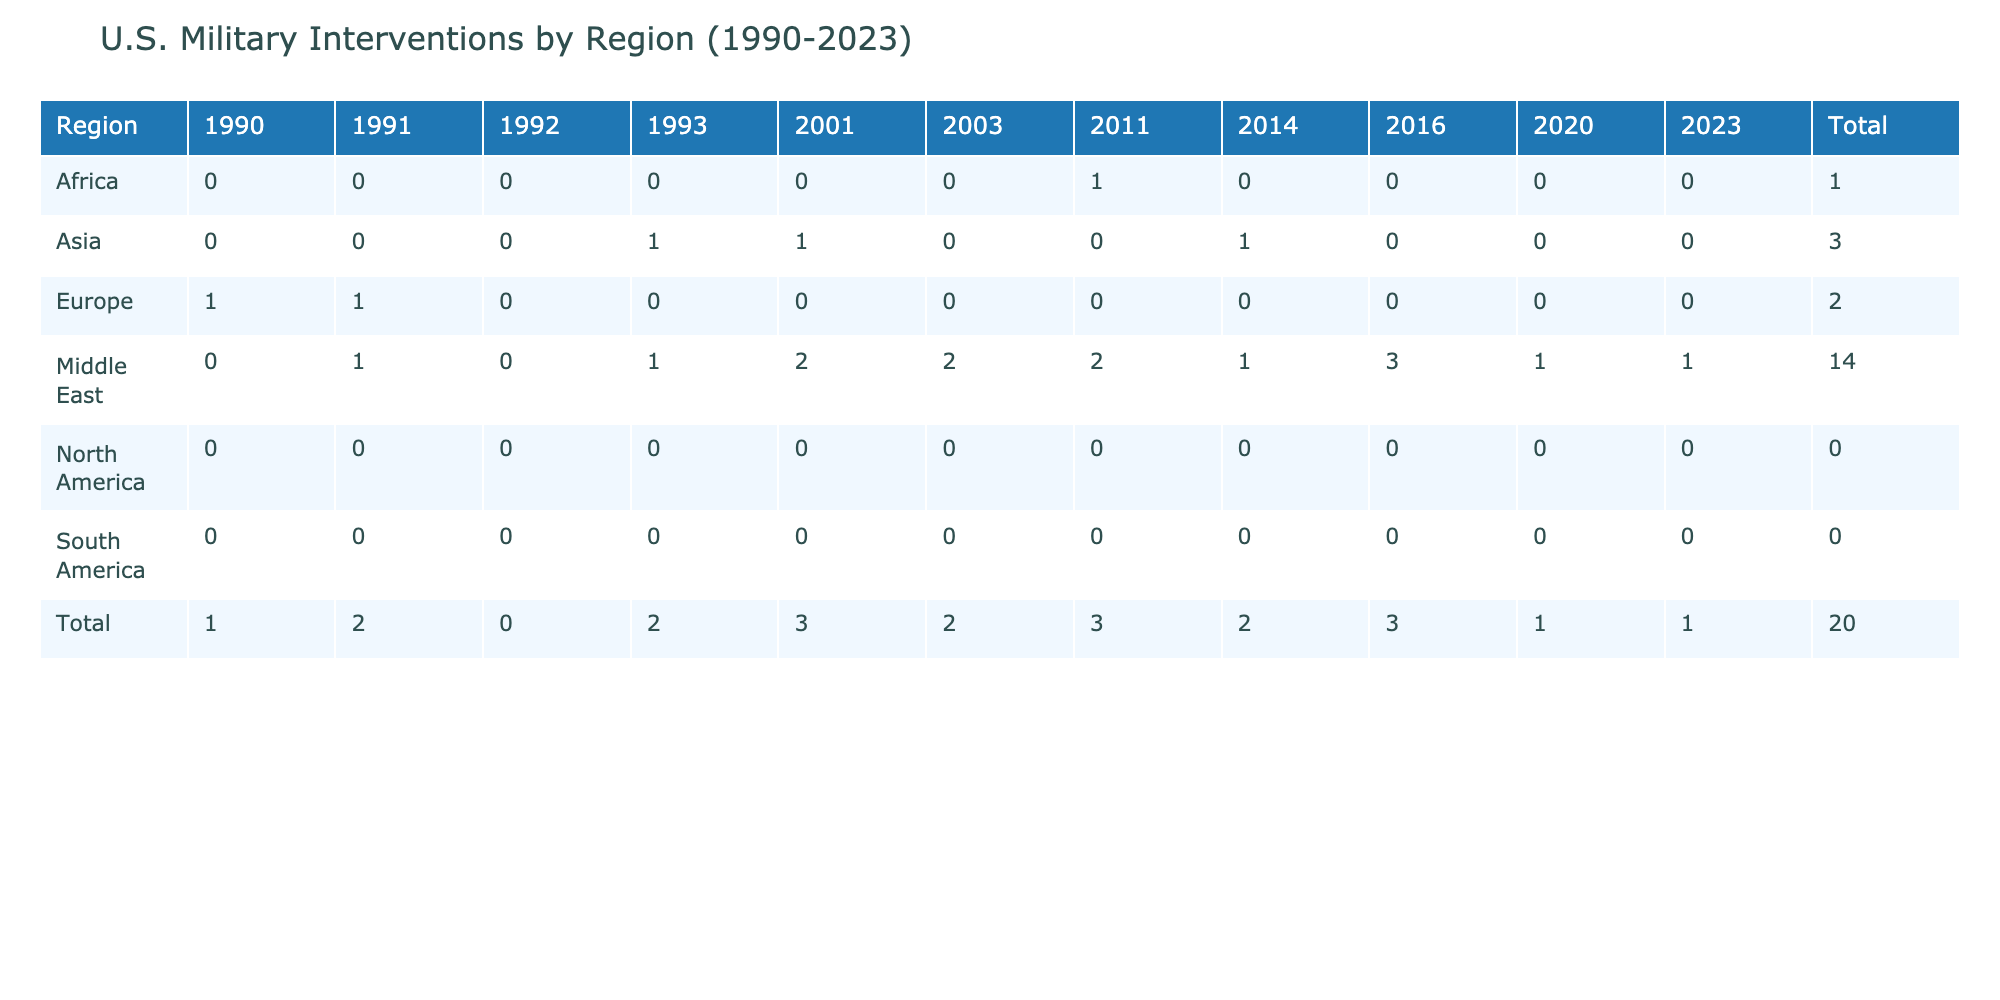What was the total number of military interventions by the U.S. in the Middle East from 1990 to 2023? To find the total number of military interventions in the Middle East, sum the values in the row corresponding to the Middle East across the years listed in the table: 0 + 1 + 0 + 1 + 2 + 2 + 2 + 1 + 1 = 10.
Answer: 10 Which region had the highest number of military interventions in 2003? Looking at the table for the year 2003, the Middle East had 2 military interventions, while all other regions had 0. Therefore, the Middle East had the highest number of interventions in that year.
Answer: Middle East Did the U.S. conduct any military interventions in South America between 1990 and 2023? Checking the row for South America, all values from 1990 to 2023 are 0, indicating there were no military interventions conducted in South America during this time period.
Answer: No What was the average number of military interventions per year in Africa from 1990 to 2023? The data shows military interventions in Africa for the years: 0 (1990) + 0 (1991) + 0 (1992) + 0 (1993) + 1 (2011) + 0 (2014) + 0 (2016) + 0 (2020) + 0 (2023) = 1 total across 9 years. To find the average, divide the total by the number of years: 1/9 = approximately 0.11 interventions per year.
Answer: Approximately 0.11 In which year did the U.S. have the most military interventions in Asia? Inspecting the row for Asia, the year's data show: 0 (1990), 0 (1991), 0 (1992), 1 (1993), 1 (2001), 0 (2003), 0 (2011), 1 (2014), 0 (2016), 0 (2020), and 0 (2023). The highest count is 1, which occurred in 1993, 2001, and 2014.
Answer: 1993, 2001, and 2014 What is the difference in the total number of military interventions between Europe and the Middle East from 1990 to 2023? To find the difference, calculate the totals for each region: Europe has 1 (1990) + 1 (1991) + 0 (1992) + 0 (1993) + 0 (2001) + 0 (2003) + 0 (2011) + 0 (2014) + 0 (2016) + 0 (2020) + 0 (2023) = 2. The Middle East total is 10 as calculated earlier. The difference is 10 (Middle East) - 2 (Europe) = 8.
Answer: 8 